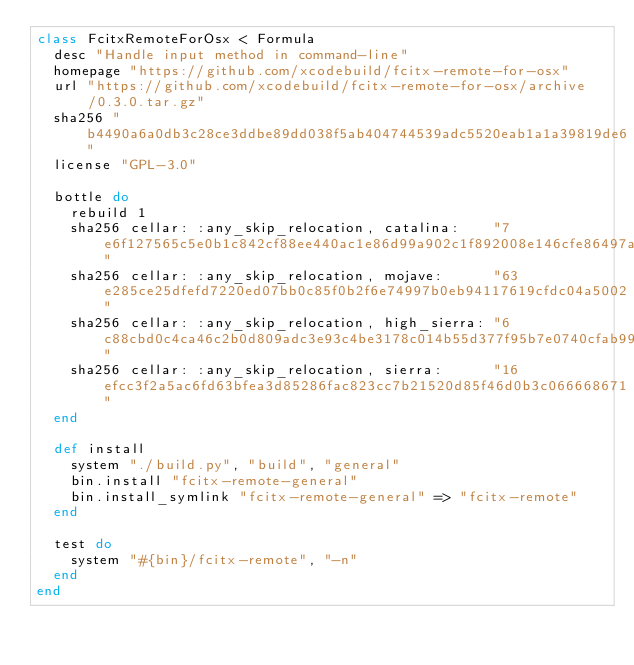Convert code to text. <code><loc_0><loc_0><loc_500><loc_500><_Ruby_>class FcitxRemoteForOsx < Formula
  desc "Handle input method in command-line"
  homepage "https://github.com/xcodebuild/fcitx-remote-for-osx"
  url "https://github.com/xcodebuild/fcitx-remote-for-osx/archive/0.3.0.tar.gz"
  sha256 "b4490a6a0db3c28ce3ddbe89dd038f5ab404744539adc5520eab1a1a39819de6"
  license "GPL-3.0"

  bottle do
    rebuild 1
    sha256 cellar: :any_skip_relocation, catalina:    "7e6f127565c5e0b1c842cf88ee440ac1e86d99a902c1f892008e146cfe86497a"
    sha256 cellar: :any_skip_relocation, mojave:      "63e285ce25dfefd7220ed07bb0c85f0b2f6e74997b0eb94117619cfdc04a5002"
    sha256 cellar: :any_skip_relocation, high_sierra: "6c88cbd0c4ca46c2b0d809adc3e93c4be3178c014b55d377f95b7e0740cfab99"
    sha256 cellar: :any_skip_relocation, sierra:      "16efcc3f2a5ac6fd63bfea3d85286fac823cc7b21520d85f46d0b3c066668671"
  end

  def install
    system "./build.py", "build", "general"
    bin.install "fcitx-remote-general"
    bin.install_symlink "fcitx-remote-general" => "fcitx-remote"
  end

  test do
    system "#{bin}/fcitx-remote", "-n"
  end
end
</code> 